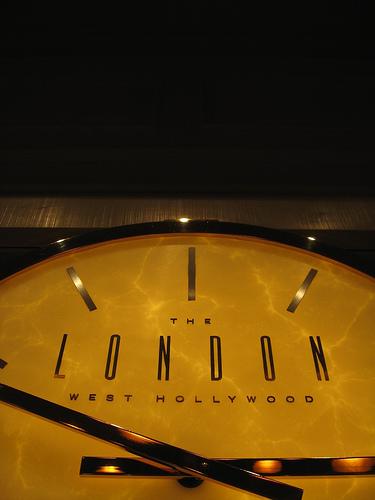What does the clock have written on it?
Quick response, please. London west hollywood. Roughly what time is it?
Short answer required. 2:49. How many words are on the clock?
Concise answer only. 4. 